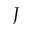Convert formula to latex. <formula><loc_0><loc_0><loc_500><loc_500>J</formula> 